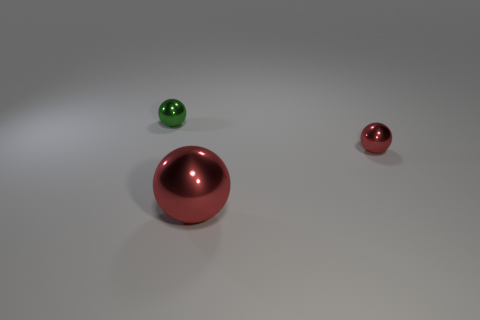Add 1 big metallic spheres. How many objects exist? 4 Add 3 small purple shiny objects. How many small purple shiny objects exist? 3 Subtract 0 green cylinders. How many objects are left? 3 Subtract all large metal objects. Subtract all big yellow shiny balls. How many objects are left? 2 Add 2 large shiny spheres. How many large shiny spheres are left? 3 